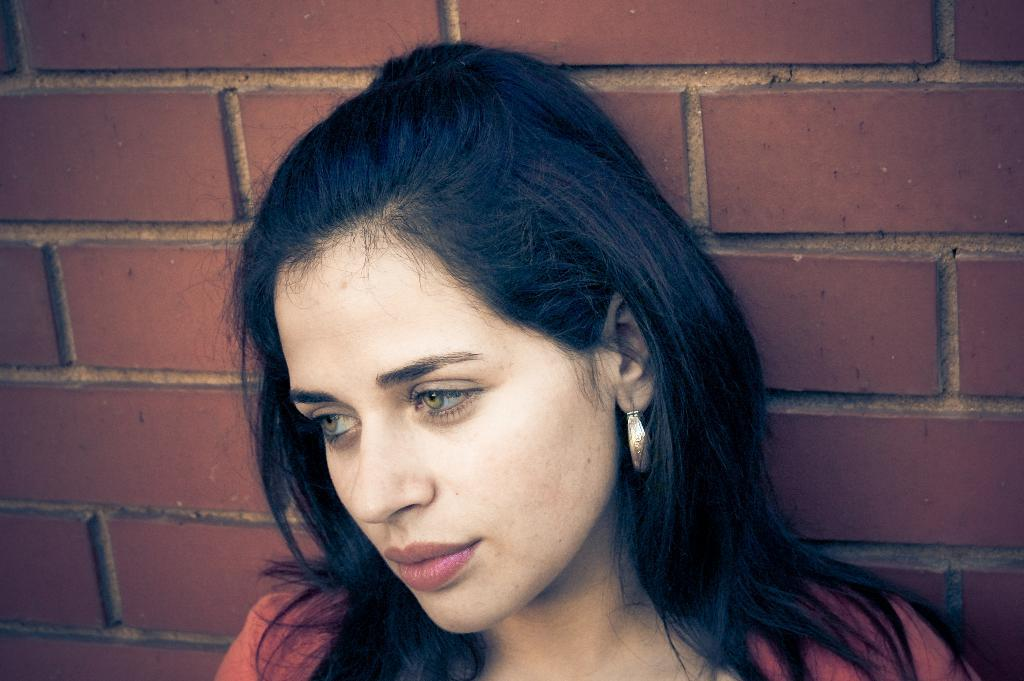Who is present in the image? There is a woman in the image. What can be seen in the background of the image? There is a wall in the background of the image. What type of drum can be heard in the background of the image? There is no drum present in the image, nor can any sounds be heard from the image. 